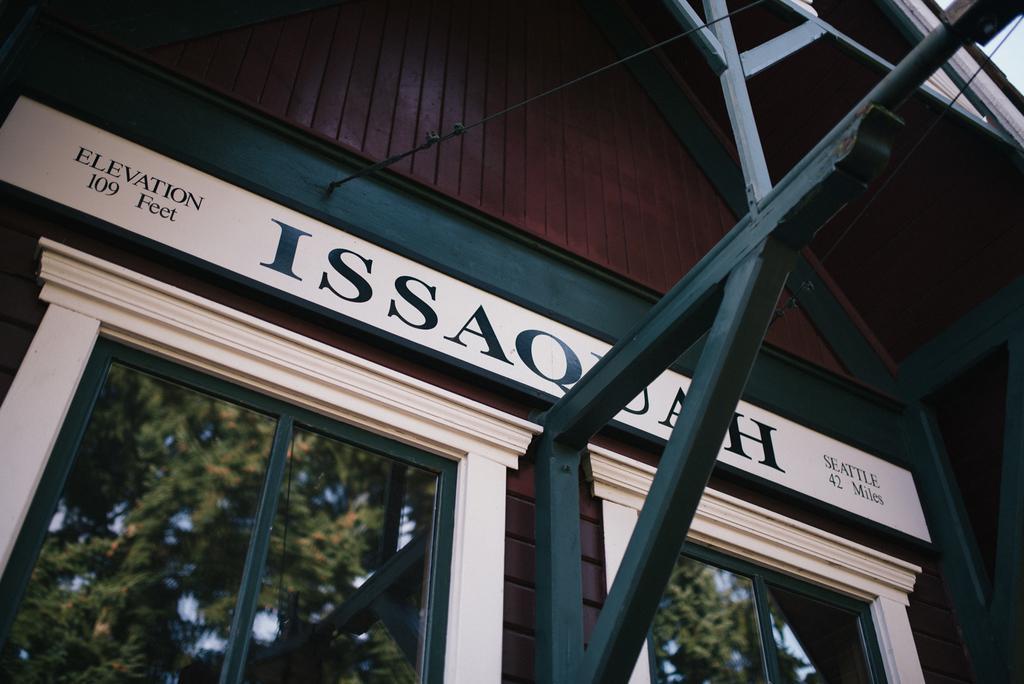Can you describe this image briefly? It looks like a building and these are the windows. On the glass windows we can see the reflection of trees and here we can see the text. 